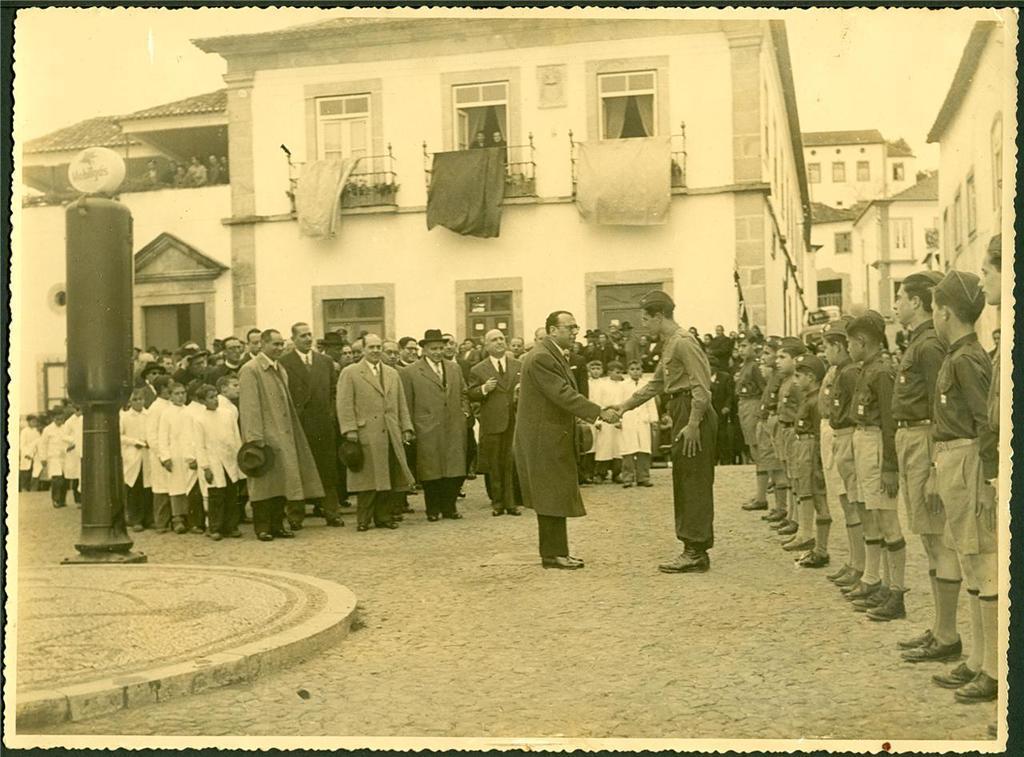In one or two sentences, can you explain what this image depicts? This image is taken on a photograph. This image is a black and white image. At the bottom of the image there is a floor. In the background there are a few buildings with walls, windows, doors and roofs. In the middle of the image many people are standing on the floor. On the right side of the image little soldiers are standing. On the left side of the image there is a pole with a street light. 